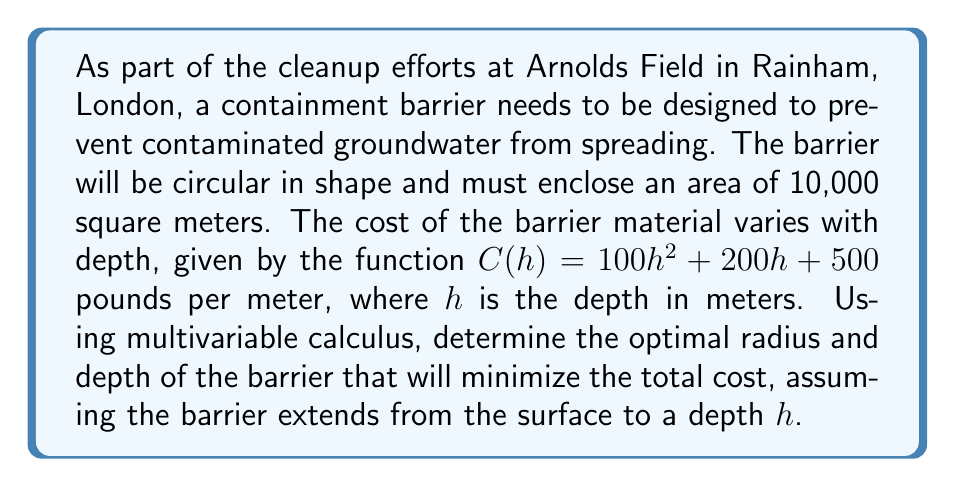Can you solve this math problem? Let's approach this problem step by step:

1) First, we need to express the total cost as a function of radius $r$ and depth $h$:

   Total Cost = Circumference × Cost per meter
   $$TC(r,h) = 2\pi r(100h^2 + 200h + 500)$$

2) We have a constraint that the area must be 10,000 square meters:
   $$\pi r^2 = 10000$$
   $$r = \sqrt{\frac{10000}{\pi}} \approx 56.42$$

3) Substituting this into our total cost function:
   $$TC(h) = 2\pi \sqrt{\frac{10000}{\pi}}(100h^2 + 200h + 500)$$
   $$= 200\sqrt{10000\pi}(100h^2 + 200h + 500)$$

4) To find the minimum cost, we differentiate with respect to $h$ and set to zero:
   $$\frac{dTC}{dh} = 200\sqrt{10000\pi}(200h + 200) = 0$$

5) Solving this equation:
   $$200h + 200 = 0$$
   $$h = -1$$

6) Since depth cannot be negative, and the second derivative is positive (indicating a minimum), the lowest possible non-negative value for $h$ will give us the minimum cost. Therefore, $h = 0$.

7) Substituting back into our radius equation:
   $$r = \sqrt{\frac{10000}{\pi}} \approx 56.42$$

8) The minimum total cost is:
   $$TC = 2\pi(56.42)(500) \approx 177,079.63$$
Answer: The optimal shape for the containment barrier is a circle with radius approximately 56.42 meters and depth 0 meters (i.e., a surface-level barrier). The minimum total cost is approximately 177,079.63 pounds. 